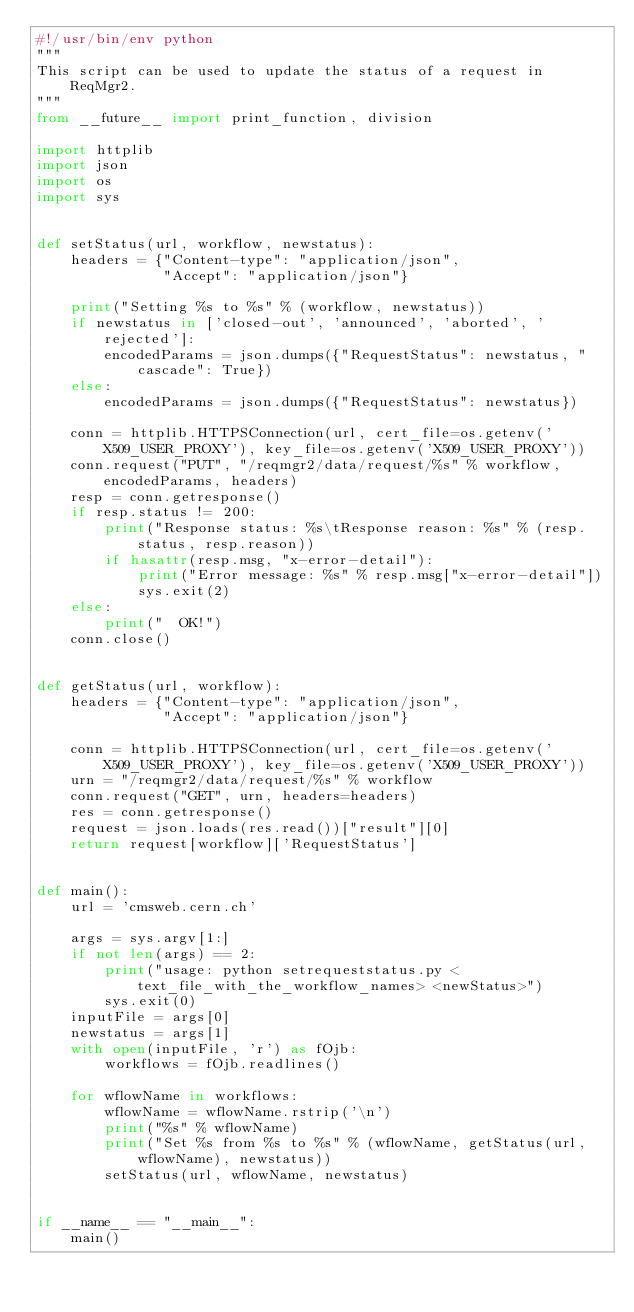<code> <loc_0><loc_0><loc_500><loc_500><_Python_>#!/usr/bin/env python
"""
This script can be used to update the status of a request in ReqMgr2.
"""
from __future__ import print_function, division

import httplib
import json
import os
import sys


def setStatus(url, workflow, newstatus):
    headers = {"Content-type": "application/json",
               "Accept": "application/json"}

    print("Setting %s to %s" % (workflow, newstatus))
    if newstatus in ['closed-out', 'announced', 'aborted', 'rejected']:
        encodedParams = json.dumps({"RequestStatus": newstatus, "cascade": True})
    else:
        encodedParams = json.dumps({"RequestStatus": newstatus})

    conn = httplib.HTTPSConnection(url, cert_file=os.getenv('X509_USER_PROXY'), key_file=os.getenv('X509_USER_PROXY'))
    conn.request("PUT", "/reqmgr2/data/request/%s" % workflow, encodedParams, headers)
    resp = conn.getresponse()
    if resp.status != 200:
        print("Response status: %s\tResponse reason: %s" % (resp.status, resp.reason))
        if hasattr(resp.msg, "x-error-detail"):
            print("Error message: %s" % resp.msg["x-error-detail"])
            sys.exit(2)
    else:
        print("  OK!")
    conn.close()


def getStatus(url, workflow):
    headers = {"Content-type": "application/json",
               "Accept": "application/json"}

    conn = httplib.HTTPSConnection(url, cert_file=os.getenv('X509_USER_PROXY'), key_file=os.getenv('X509_USER_PROXY'))
    urn = "/reqmgr2/data/request/%s" % workflow
    conn.request("GET", urn, headers=headers)
    res = conn.getresponse()
    request = json.loads(res.read())["result"][0]
    return request[workflow]['RequestStatus']


def main():
    url = 'cmsweb.cern.ch'

    args = sys.argv[1:]
    if not len(args) == 2:
        print("usage: python setrequeststatus.py <text_file_with_the_workflow_names> <newStatus>")
        sys.exit(0)
    inputFile = args[0]
    newstatus = args[1]
    with open(inputFile, 'r') as fOjb:
        workflows = fOjb.readlines()

    for wflowName in workflows:
        wflowName = wflowName.rstrip('\n')
        print("%s" % wflowName)
        print("Set %s from %s to %s" % (wflowName, getStatus(url, wflowName), newstatus))
        setStatus(url, wflowName, newstatus)


if __name__ == "__main__":
    main()
</code> 